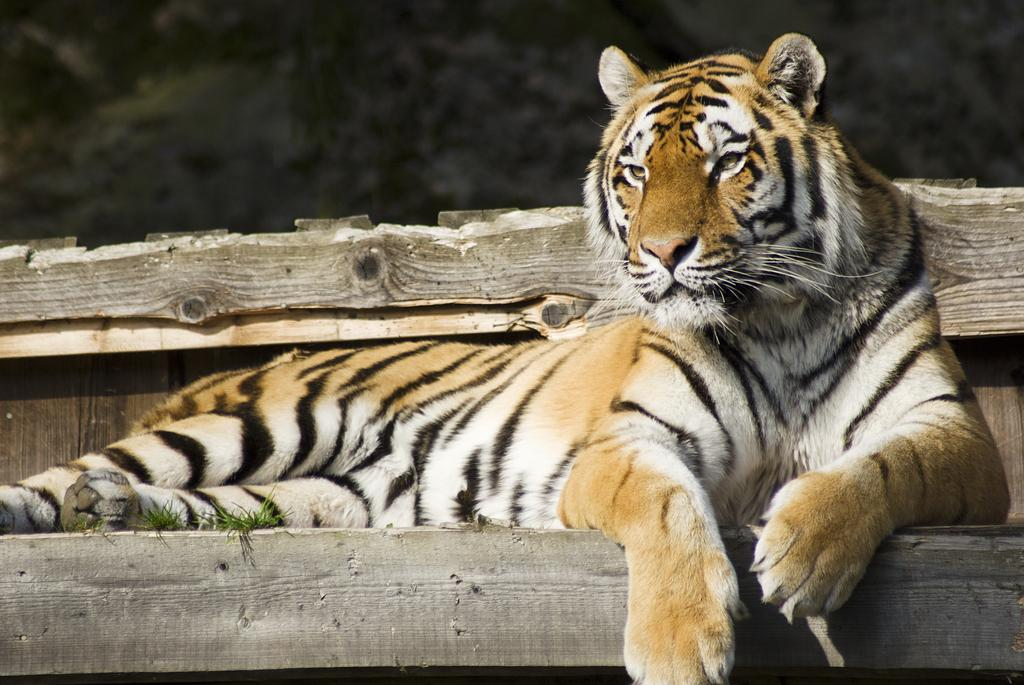What is the main subject of the picture? The main subject of the picture is a tiger. Where is the tiger located in the image? The tiger is sitting in the center of the picture. What is the tiger sitting on? The tiger is sitting on a wooden object. What can be seen in the background of the image? There are trees in the background of the image. What type of sheet is covering the tiger in the image? There is no sheet covering the tiger in the image; the tiger is sitting on a wooden object. In which direction is the tiger facing in the image? The provided facts do not specify the direction the tiger is facing, so it cannot be determined from the image. 